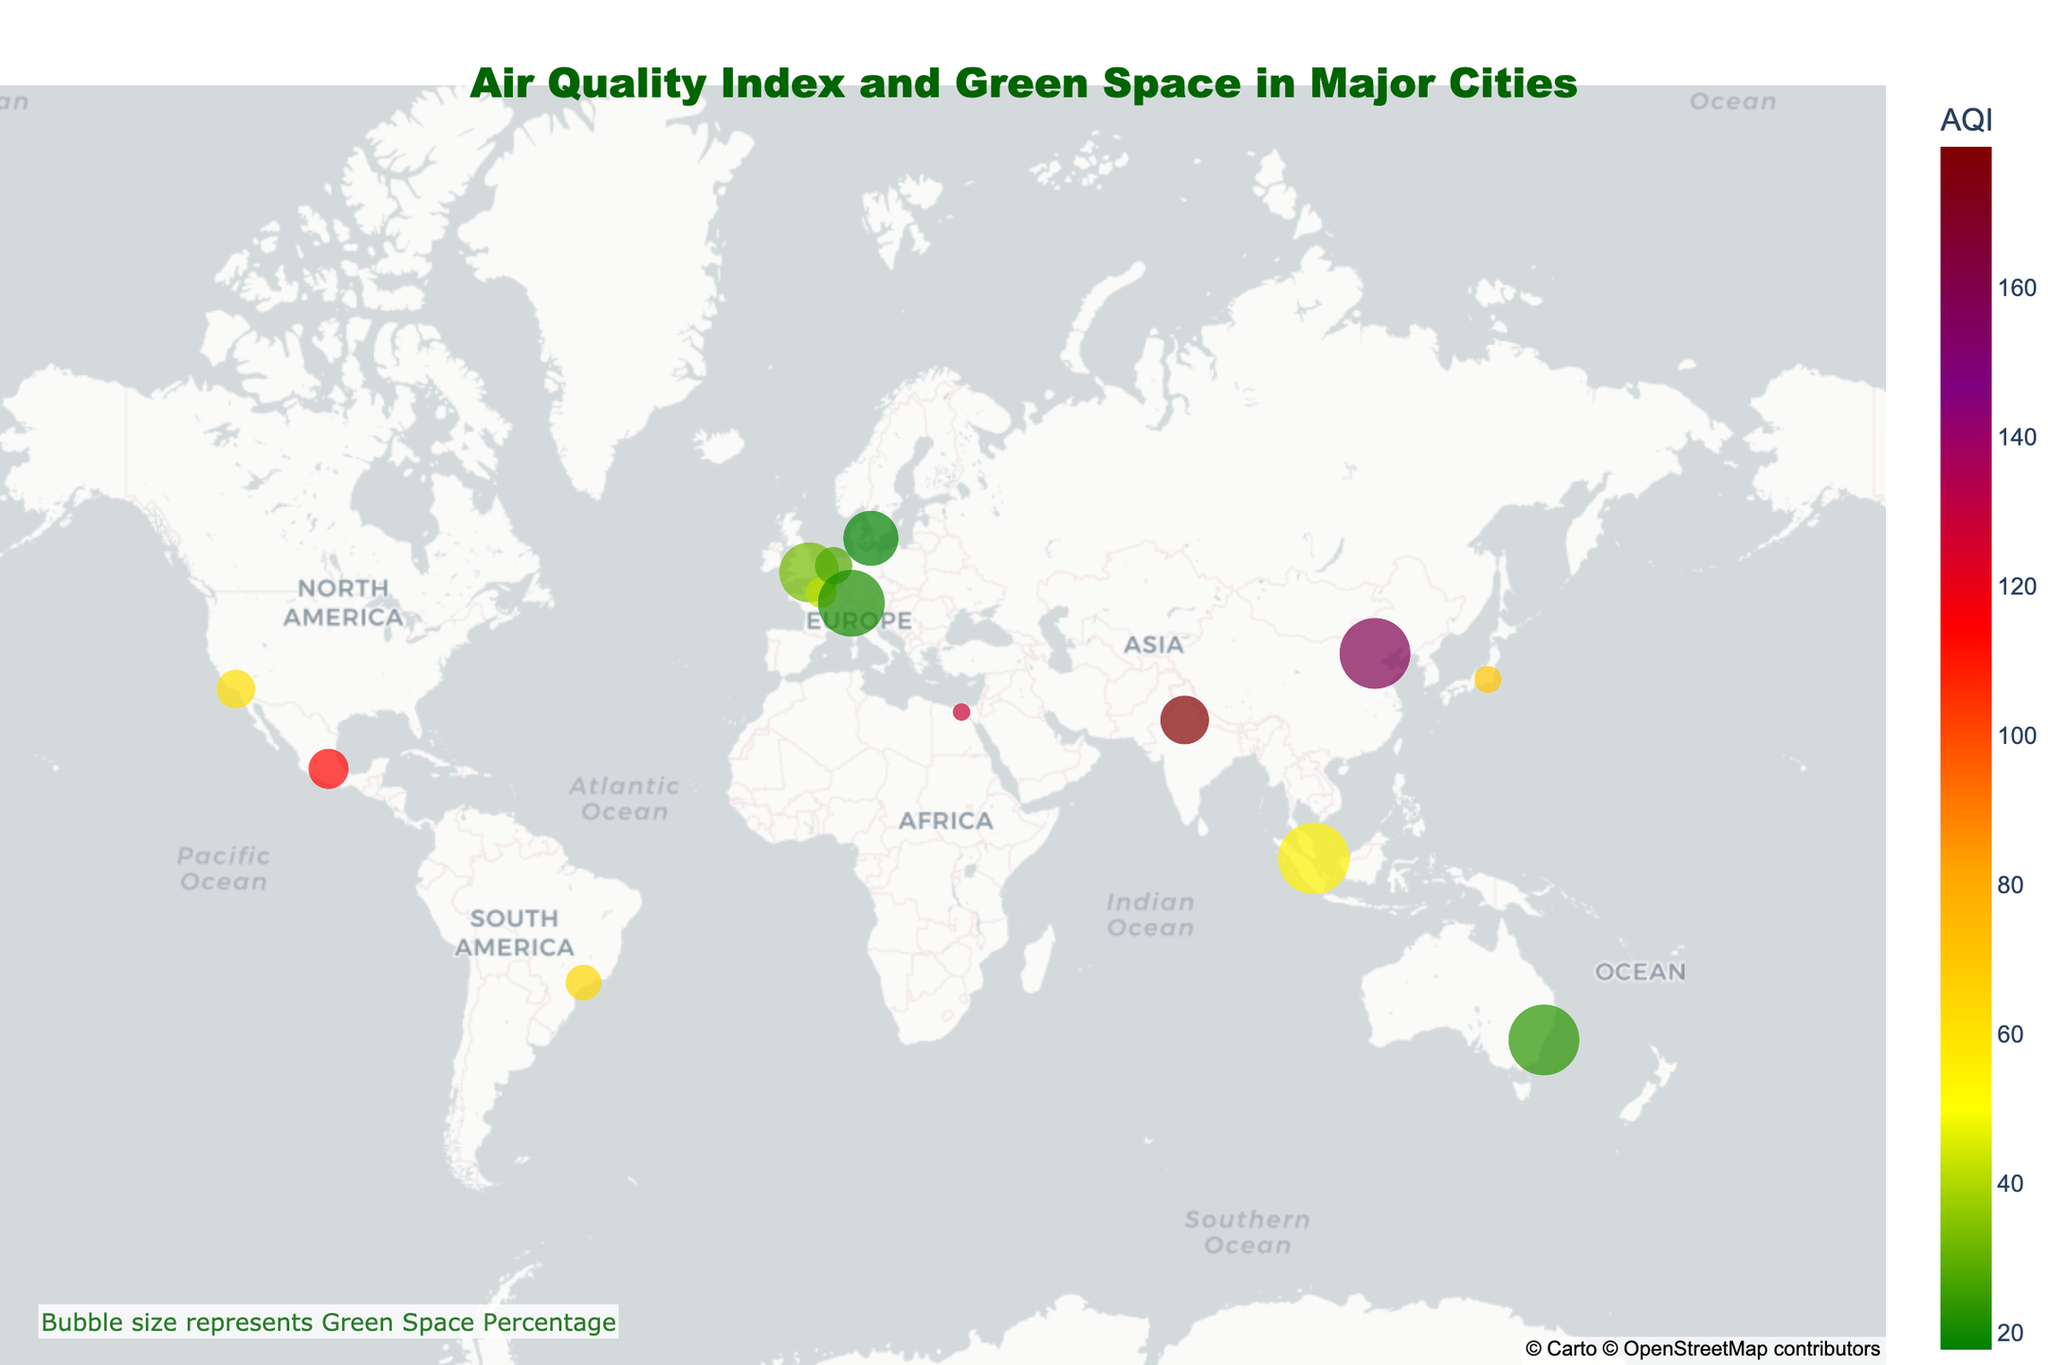Which city has the highest Air Quality Index (AQI) level? By looking at the colored markers on the map and noting the AQI levels in the hover information, New Delhi has the highest AQI level of 179.
Answer: New Delhi Which city has the highest percentage of green space? Hover over each city and compare the Green Space Percentage values shown. Singapore has the highest green space percentage of 47%.
Answer: Singapore What is the main pollutant in London? Hover over London on the map to see the hover data, which shows NO2 as the main pollutant in London.
Answer: NO2 How does the AQI level of Los Angeles compare to that of São Paulo? Hover over both Los Angeles and São Paulo on the map. Los Angeles has an AQI of 62, while São Paulo has an AQI of 65. São Paulo has a higher AQI level than Los Angeles.
Answer: São Paulo has a higher AQI level Which city has the lowest AQI level, and what is it? Hover over each city to find the AQI levels, and Sydney has the lowest AQI level of 23.
Answer: Sydney, 23 What is the average AQI level of the cities where the main pollutant is PM2.5? Identify the cities where the main pollutant is PM2.5 (Beijing, Tokyo, São Paulo, Sydney). Add their AQIs (158 + 71 + 65 + 23) and divide by 4, resulting in an average AQI of 79.25.
Answer: 79.25 Which city has a close balance between its AQI level and its green space percentage? Hover over each city and compare their AQI levels and green space percentages. Sydney has an AQI of 23 and a green space percentage of 46, showing a close balance between the two metrics.
Answer: Sydney If green space is believed to reduce AQI, which city contradicts this assumption the most? Identify the city with a high AQI but a significant percentage of green space. Beijing has an AQI of 158 and a Green Space Percentage of 46, which seems contradictory to the idea that green space reduces AQI.
Answer: Beijing How does the green space percentage of Zurich compare to that of Cairo? Hover over Zurich and Cairo to see their Green Space Percentages. Zurich has 41% green space, while Cairo has only 3%.
Answer: Zurich has significantly more green space than Cairo 